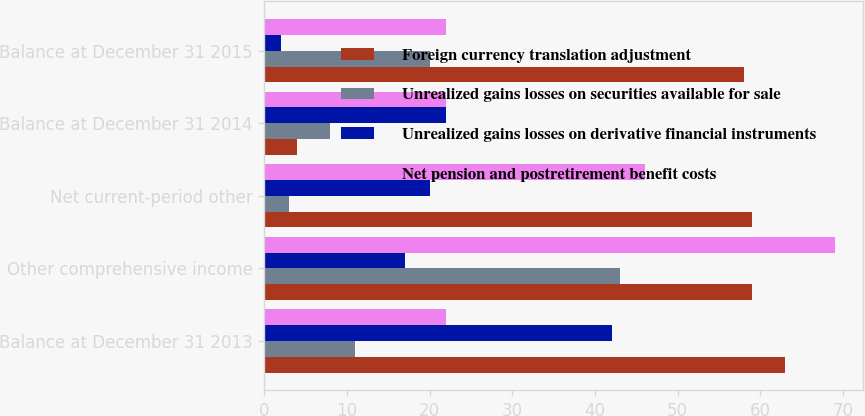Convert chart to OTSL. <chart><loc_0><loc_0><loc_500><loc_500><stacked_bar_chart><ecel><fcel>Balance at December 31 2013<fcel>Other comprehensive income<fcel>Net current-period other<fcel>Balance at December 31 2014<fcel>Balance at December 31 2015<nl><fcel>Foreign currency translation adjustment<fcel>63<fcel>59<fcel>59<fcel>4<fcel>58<nl><fcel>Unrealized gains losses on securities available for sale<fcel>11<fcel>43<fcel>3<fcel>8<fcel>20<nl><fcel>Unrealized gains losses on derivative financial instruments<fcel>42<fcel>17<fcel>20<fcel>22<fcel>2<nl><fcel>Net pension and postretirement benefit costs<fcel>22<fcel>69<fcel>46<fcel>22<fcel>22<nl></chart> 